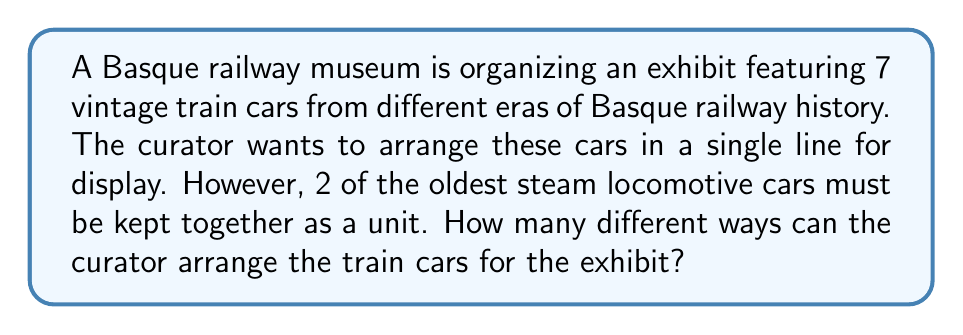Could you help me with this problem? Let's approach this step-by-step:

1) First, we need to recognize that the 2 oldest steam locomotive cars must be treated as a single unit. This effectively reduces our number of elements to arrange from 7 to 6 (5 individual cars + 1 unit of 2 cars).

2) Now, we're dealing with a straightforward permutation of 6 elements. The formula for this is:

   $$P(6) = 6!$$

3) Let's calculate this:
   $$6! = 6 \times 5 \times 4 \times 3 \times 2 \times 1 = 720$$

4) However, we're not done yet. Remember that the 2 cars within the unit can also be arranged in 2 ways (Car A, Car B or Car B, Car A).

5) To account for this, we need to multiply our result by 2:

   $$720 \times 2 = 1440$$

Therefore, the curator can arrange the train cars in 1440 different ways.
Answer: 1440 